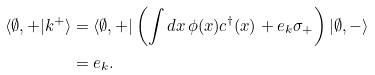<formula> <loc_0><loc_0><loc_500><loc_500>\langle \emptyset , + | k ^ { + } \rangle & = \langle \emptyset , + | \left ( \int d x \, \phi ( x ) c ^ { \dagger } ( x ) + e _ { k } \sigma _ { + } \right ) | \emptyset , - \rangle \\ & = e _ { k } .</formula> 